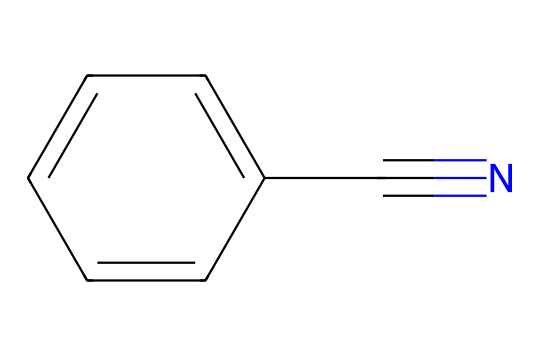What is the name of this chemical? The structure provided (c1ccccc1C#N) corresponds to benzonitrile, which is indicated by the presence of a benzene ring (c1ccccc1) and a nitrile group (C#N).
Answer: benzonitrile How many carbon atoms are in benzonitrile? Analyzing the SMILES, there are six carbon atoms in the benzene ring and one from the nitrile group, totaling seven carbon atoms overall.
Answer: seven What type of functional group does this chemical contain? The presence of the C#N indicates that the molecule has a nitrile functional group. A nitrile is characterized by a carbon triple-bonded to a nitrogen atom.
Answer: nitrile Is benzonitrile polar or nonpolar? Considering the structure, benzonitrile has a polar nitrile group which may suggest polarity, but the overall molecule is largely nonpolar due to the benzene ring, which makes it hydrophobic.
Answer: nonpolar What is the molecular formula of benzonitrile? By counting the atoms from the stylized representation, we find six carbons, five hydrogens, and one nitrogen, leading to the molecular formula C7H5N.
Answer: C7H5N How many hydrogen atoms does benzonitrile have? From the chemical structure, there are five hydrogen atoms attached to the benzene ring. The nitrile group does not contribute any additional hydrogen atoms.
Answer: five What type of chemical reaction is commonly used to synthesize benzonitrile? To synthesize benzonitrile, a nucleophilic substitution reaction is often used, such as the reaction of benzyl chloride with sodium cyanide.
Answer: nucleophilic substitution 